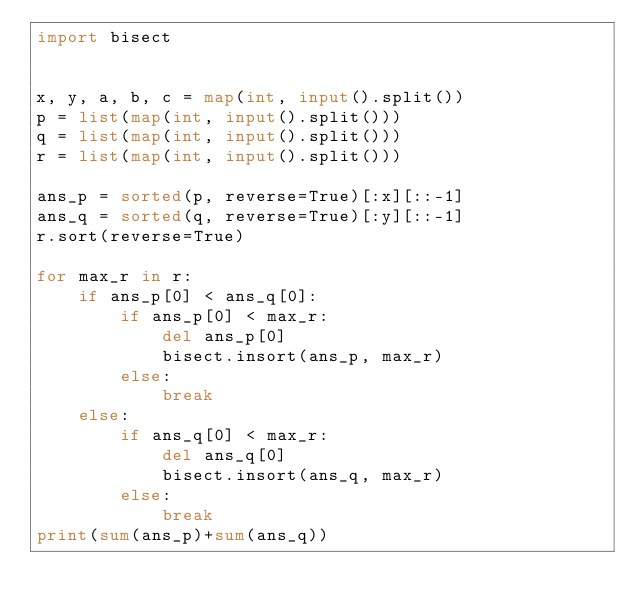<code> <loc_0><loc_0><loc_500><loc_500><_Python_>import bisect


x, y, a, b, c = map(int, input().split())
p = list(map(int, input().split()))
q = list(map(int, input().split()))
r = list(map(int, input().split()))

ans_p = sorted(p, reverse=True)[:x][::-1]
ans_q = sorted(q, reverse=True)[:y][::-1]
r.sort(reverse=True)

for max_r in r:
    if ans_p[0] < ans_q[0]:
        if ans_p[0] < max_r:
            del ans_p[0]
            bisect.insort(ans_p, max_r)
        else:
            break
    else:
        if ans_q[0] < max_r:
            del ans_q[0]
            bisect.insort(ans_q, max_r)
        else:
            break
print(sum(ans_p)+sum(ans_q))</code> 